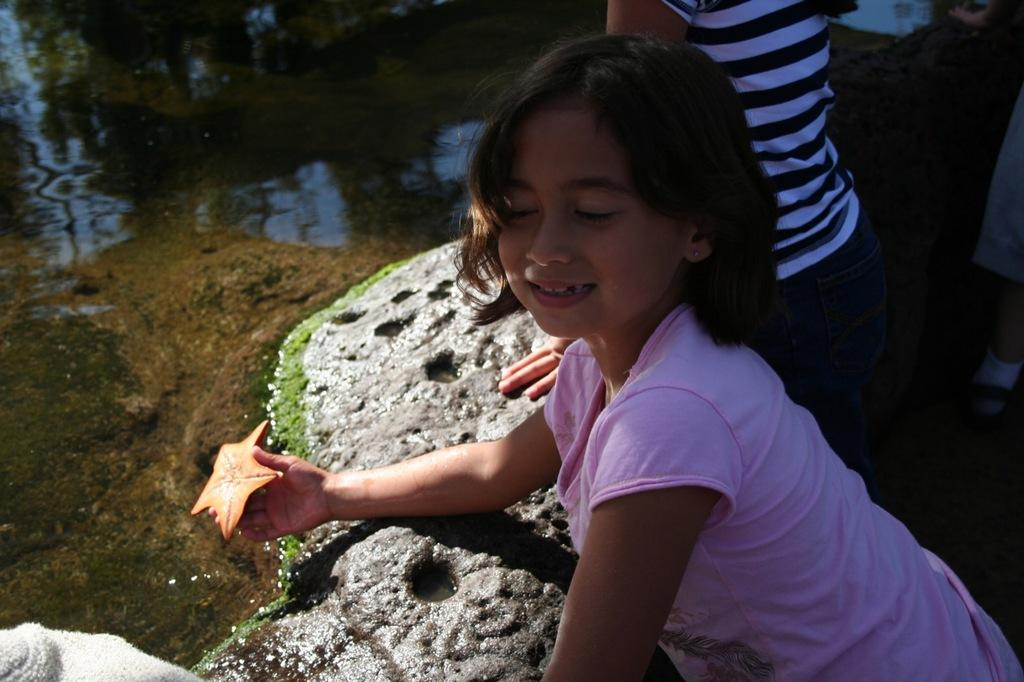Who is the main subject in the image? There is a girl in the center of the image. What is the girl holding in her hand? The girl is holding a stone in her hand. What can be seen in the background of the image? There are people in the background of the image. What is located on the left side of the image? There is water and a rock on the left side of the image. Where is the nest located in the image? There is no nest present in the image. Can you read the letter that the girl is holding in the image? The girl is holding a stone, not a letter, in the image. 